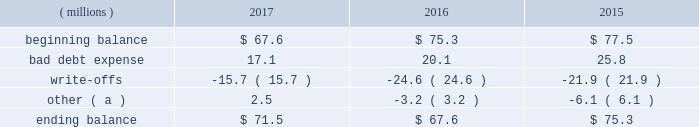Cash and cash equivalents cash equivalents include highly-liquid investments with a maturity of three months or less when purchased .
Accounts receivable and allowance for doubtful accounts accounts receivable are carried at the invoiced amounts , less an allowance for doubtful accounts , and generally do not bear interest .
The company estimates the balance of allowance for doubtful accounts by analyzing accounts receivable balances by age and applying historical write-off and collection trend rates .
The company 2019s estimates include separately providing for customer receivables based on specific circumstances and credit conditions , and when it is deemed probable that the balance is uncollectible .
Account balances are written off against the allowance when it is determined the receivable will not be recovered .
The company 2019s allowance for doubtful accounts balance also includes an allowance for the expected return of products shipped and credits related to pricing or quantities shipped of $ 15 million , $ 14 million and $ 15 million as of december 31 , 2017 , 2016 , and 2015 , respectively .
Returns and credit activity is recorded directly to sales as a reduction .
The table summarizes the activity in the allowance for doubtful accounts: .
( a ) other amounts are primarily the effects of changes in currency translations and the impact of allowance for returns and credits .
Inventory valuations inventories are valued at the lower of cost or net realizable value .
Certain u.s .
Inventory costs are determined on a last-in , first-out ( 201clifo 201d ) basis .
Lifo inventories represented 39% ( 39 % ) and 40% ( 40 % ) of consolidated inventories as of december 31 , 2017 and 2016 , respectively .
All other inventory costs are determined using either the average cost or first-in , first-out ( 201cfifo 201d ) methods .
Inventory values at fifo , as shown in note 5 , approximate replacement cost .
Property , plant and equipment property , plant and equipment assets are stated at cost .
Merchandising and customer equipment consists principally of various dispensing systems for the company 2019s cleaning and sanitizing products , dishwashing machines and process control and monitoring equipment .
Certain dispensing systems capitalized by the company are accounted for on a mass asset basis , whereby equipment is capitalized and depreciated as a group and written off when fully depreciated .
The company capitalizes both internal and external costs of development or purchase of computer software for internal use .
Costs incurred for data conversion , training and maintenance associated with capitalized software are expensed as incurred .
Expenditures for major renewals and improvements , which significantly extend the useful lives of existing plant and equipment , are capitalized and depreciated .
Expenditures for repairs and maintenance are charged to expense as incurred .
Upon retirement or disposition of plant and equipment , the cost and related accumulated depreciation are removed from the accounts and any resulting gain or loss is recognized in income .
Depreciation is charged to operations using the straight-line method over the assets 2019 estimated useful lives ranging from 5 to 40 years for buildings and leasehold improvements , 3 to 20 years for machinery and equipment , 3 to 15 years for merchandising and customer equipment and 3 to 7 years for capitalized software .
The straight-line method of depreciation reflects an appropriate allocation of the cost of the assets to earnings in proportion to the amount of economic benefits obtained by the company in each reporting period .
Depreciation expense was $ 586 million , $ 561 million and $ 560 million for 2017 , 2016 and 2015 , respectively. .
What was average percentage for lifo inventories of consolidated inventories for december 31 , 2017 and 2016? 
Computations: ((39 + 40) / 2)
Answer: 39.5. 